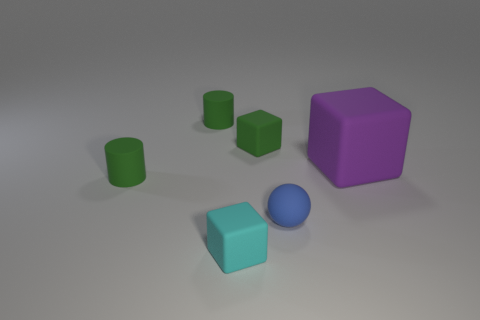Add 1 large purple blocks. How many objects exist? 7 Subtract all tiny blocks. How many blocks are left? 1 Subtract all purple cubes. How many cubes are left? 2 Subtract 1 blocks. How many blocks are left? 2 Add 2 cyan things. How many cyan things are left? 3 Add 4 blue things. How many blue things exist? 5 Subtract 1 blue spheres. How many objects are left? 5 Subtract all cylinders. How many objects are left? 4 Subtract all red cylinders. Subtract all green spheres. How many cylinders are left? 2 Subtract all cyan balls. How many green blocks are left? 1 